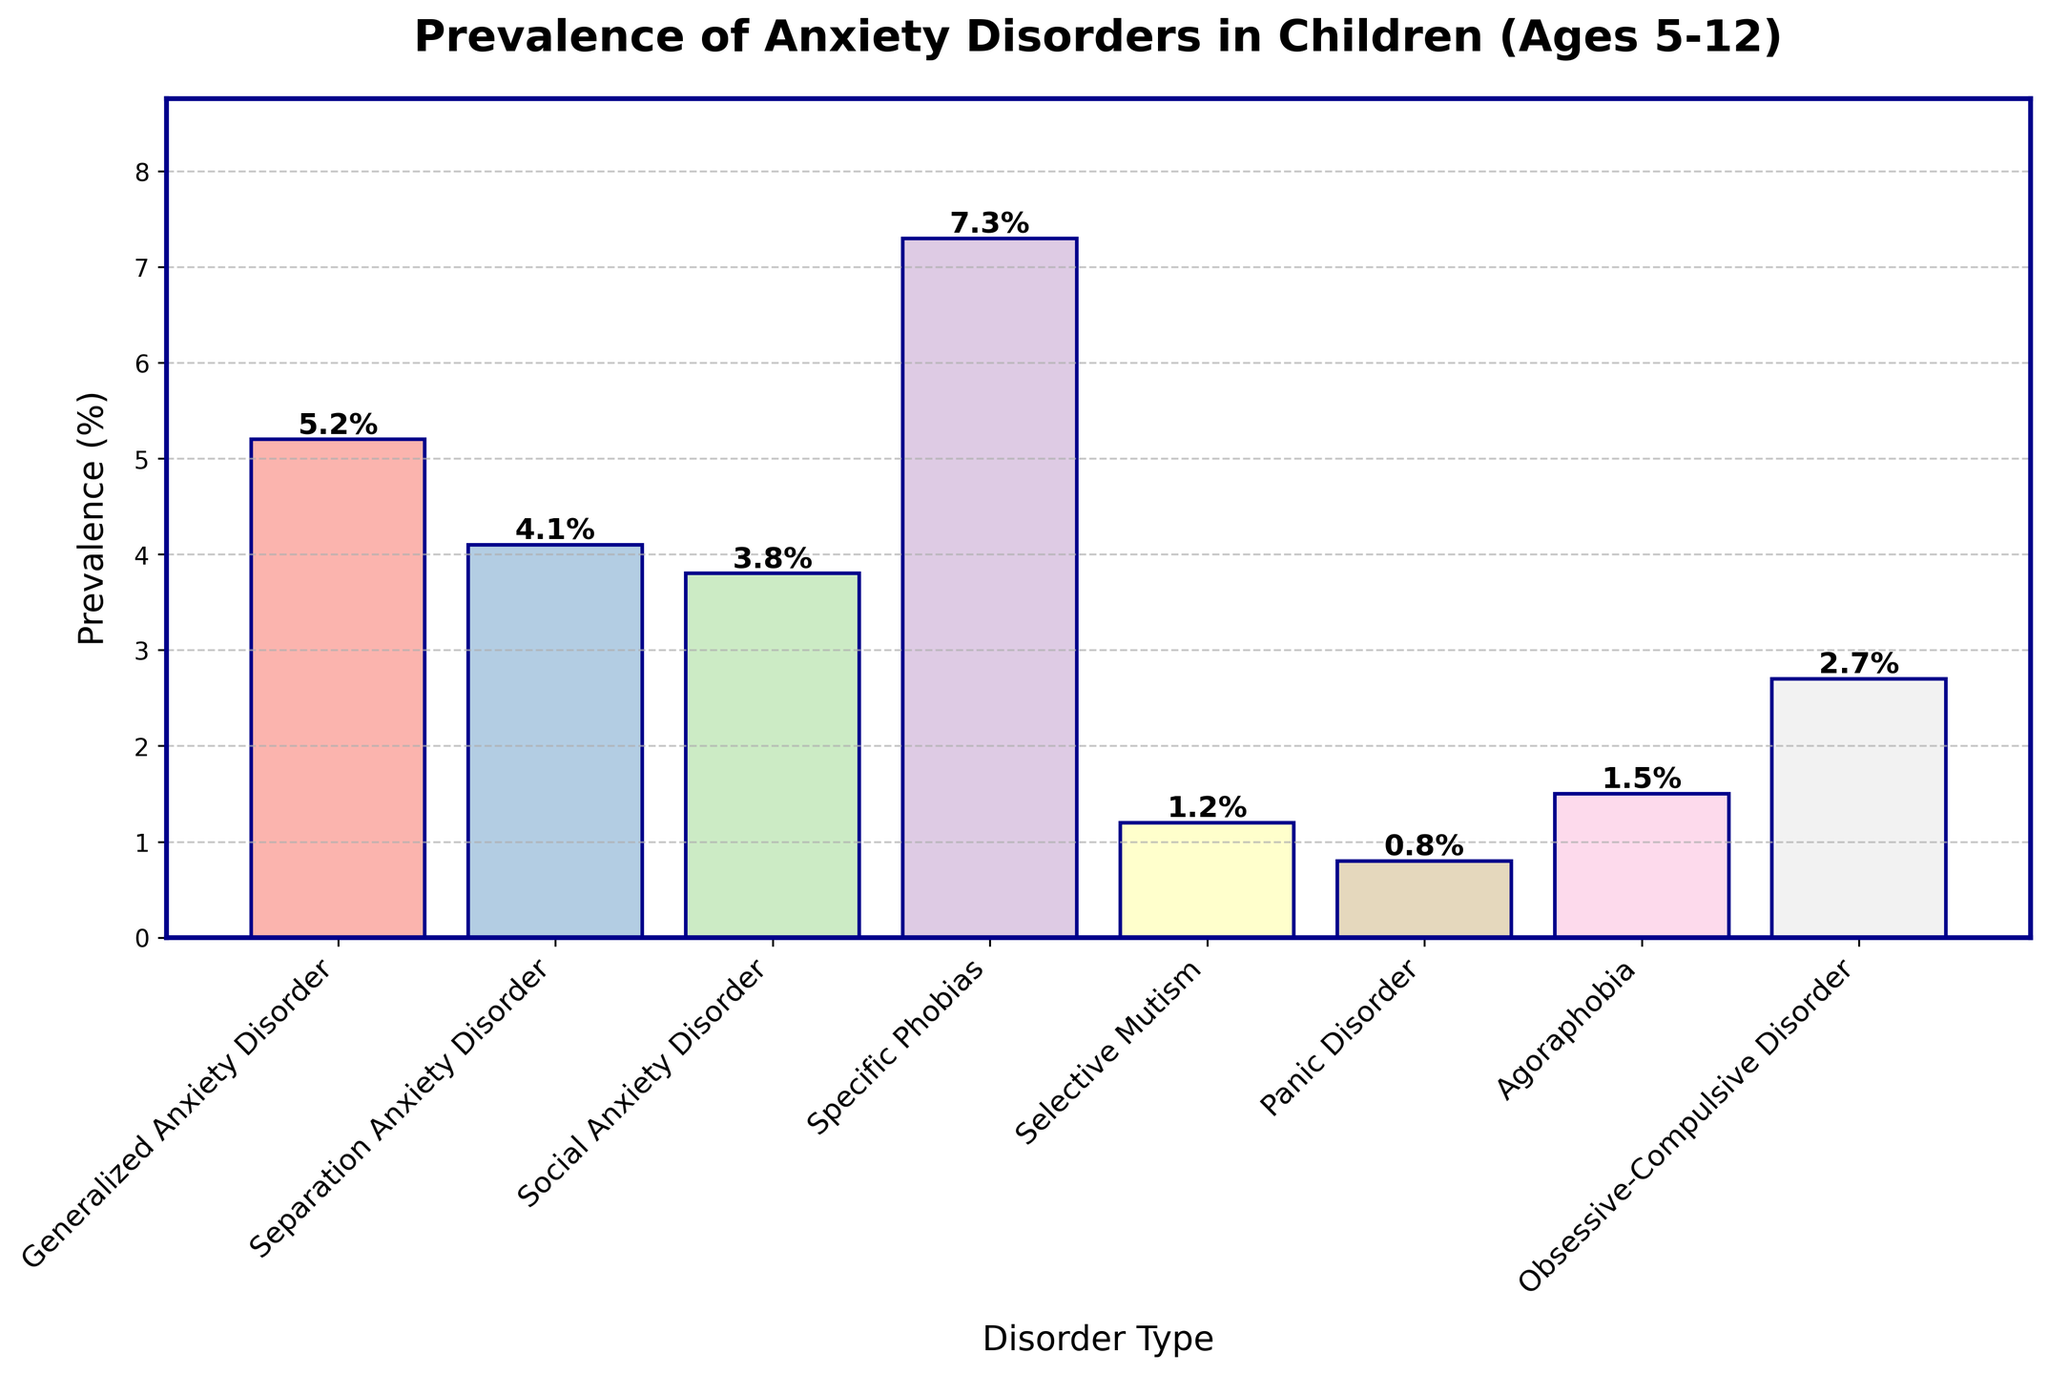What type of anxiety disorder has the highest prevalence among children aged 5-12? The bar representing Specific Phobias is the tallest among others in the figure. This implies that Specific Phobias has the highest prevalence.
Answer: Specific Phobias Which two anxiety disorders have the closest prevalence rates, and what are these rates? The bars for Separation Anxiety Disorder and Social Anxiety Disorder appear to be very close in height. Checking the labels, the rates are 4.1% and 3.8% respectively.
Answer: Separation Anxiety Disorder (4.1%) and Social Anxiety Disorder (3.8%) How much more prevalent is Generalized Anxiety Disorder compared to Panic Disorder? Compare the heights of the bars for Generalized Anxiety Disorder and Panic Disorder. The prevalence rates are 5.2% and 0.8% respectively. Subtracting the lower value from the higher value: 5.2% - 0.8% = 4.4%.
Answer: 4.4% What is the total prevalence of the top three anxiety disorders in terms of prevalence rates? Identify the three disorders with the highest bars, which are Specific Phobias, Generalized Anxiety Disorder, and Separation Anxiety Disorder with the rates of 7.3%, 5.2%, and 4.1% respectively. Adding these values together: 7.3% + 5.2% + 4.1% = 16.6%.
Answer: 16.6% Among the anxiety disorders listed, which one has a prevalence rate closest to 1.0%? The bars for Selective Mutism and Agoraphobia are close to 1.0%. Checking the labels, Selective Mutism has a prevalence rate of 1.2%.
Answer: Selective Mutism (1.2%) How does the prevalence of Obsessive-Compulsive Disorder compare to that of Agoraphobia? Compare the heights of the bars for Obsessive-Compulsive Disorder (2.7%) and Agoraphobia (1.5%). Obsessive-Compulsive Disorder has a higher prevalence.
Answer: Obsessive-Compulsive Disorder is more prevalent What is the average prevalence of the anxiety disorders listed? Sum all the prevalence rates and divide by the number of disorders. The rates are: 5.2%, 4.1%, 3.8%, 7.3%, 1.2%, 0.8%, 1.5%, and 2.7%. The sum is 5.2 + 4.1 + 3.8 + 7.3 + 1.2 + 0.8 + 1.5 + 2.7 = 26.6. There are 8 disorders, so the average is 26.6 / 8 = 3.325%.
Answer: 3.325% Which anxiety disorder has a prevalence rate less than 1.0%? The bar for Panic Disorder is the only one that has a prevalence rate less than 1.0%, specifically at 0.8%.
Answer: Panic Disorder (0.8%) What's the difference in prevalence between Social Anxiety Disorder and Selective Mutism? Compare the heights of the bars for Social Anxiety Disorder and Selective Mutism. The rates are 3.8% and 1.2% respectively. Subtract the lower value from the higher value: 3.8% - 1.2% = 2.6%.
Answer: 2.6% 